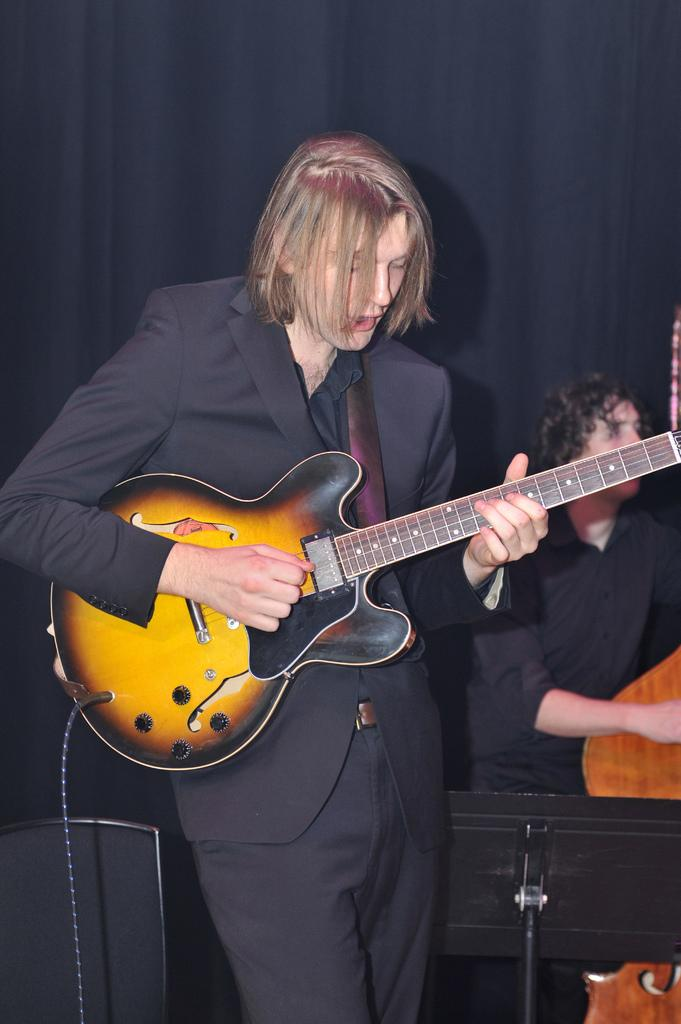What is the man in the image holding? The man is holding a guitar. What is the man doing with the guitar? The man is playing the guitar. Can you describe the other person in the image? There is another person in the background of the image, but no specific details are provided. What type of coil is the governor using to control the impulse in the image? There is no governor, coil, or impulse present in the image; it features a man playing a guitar. 